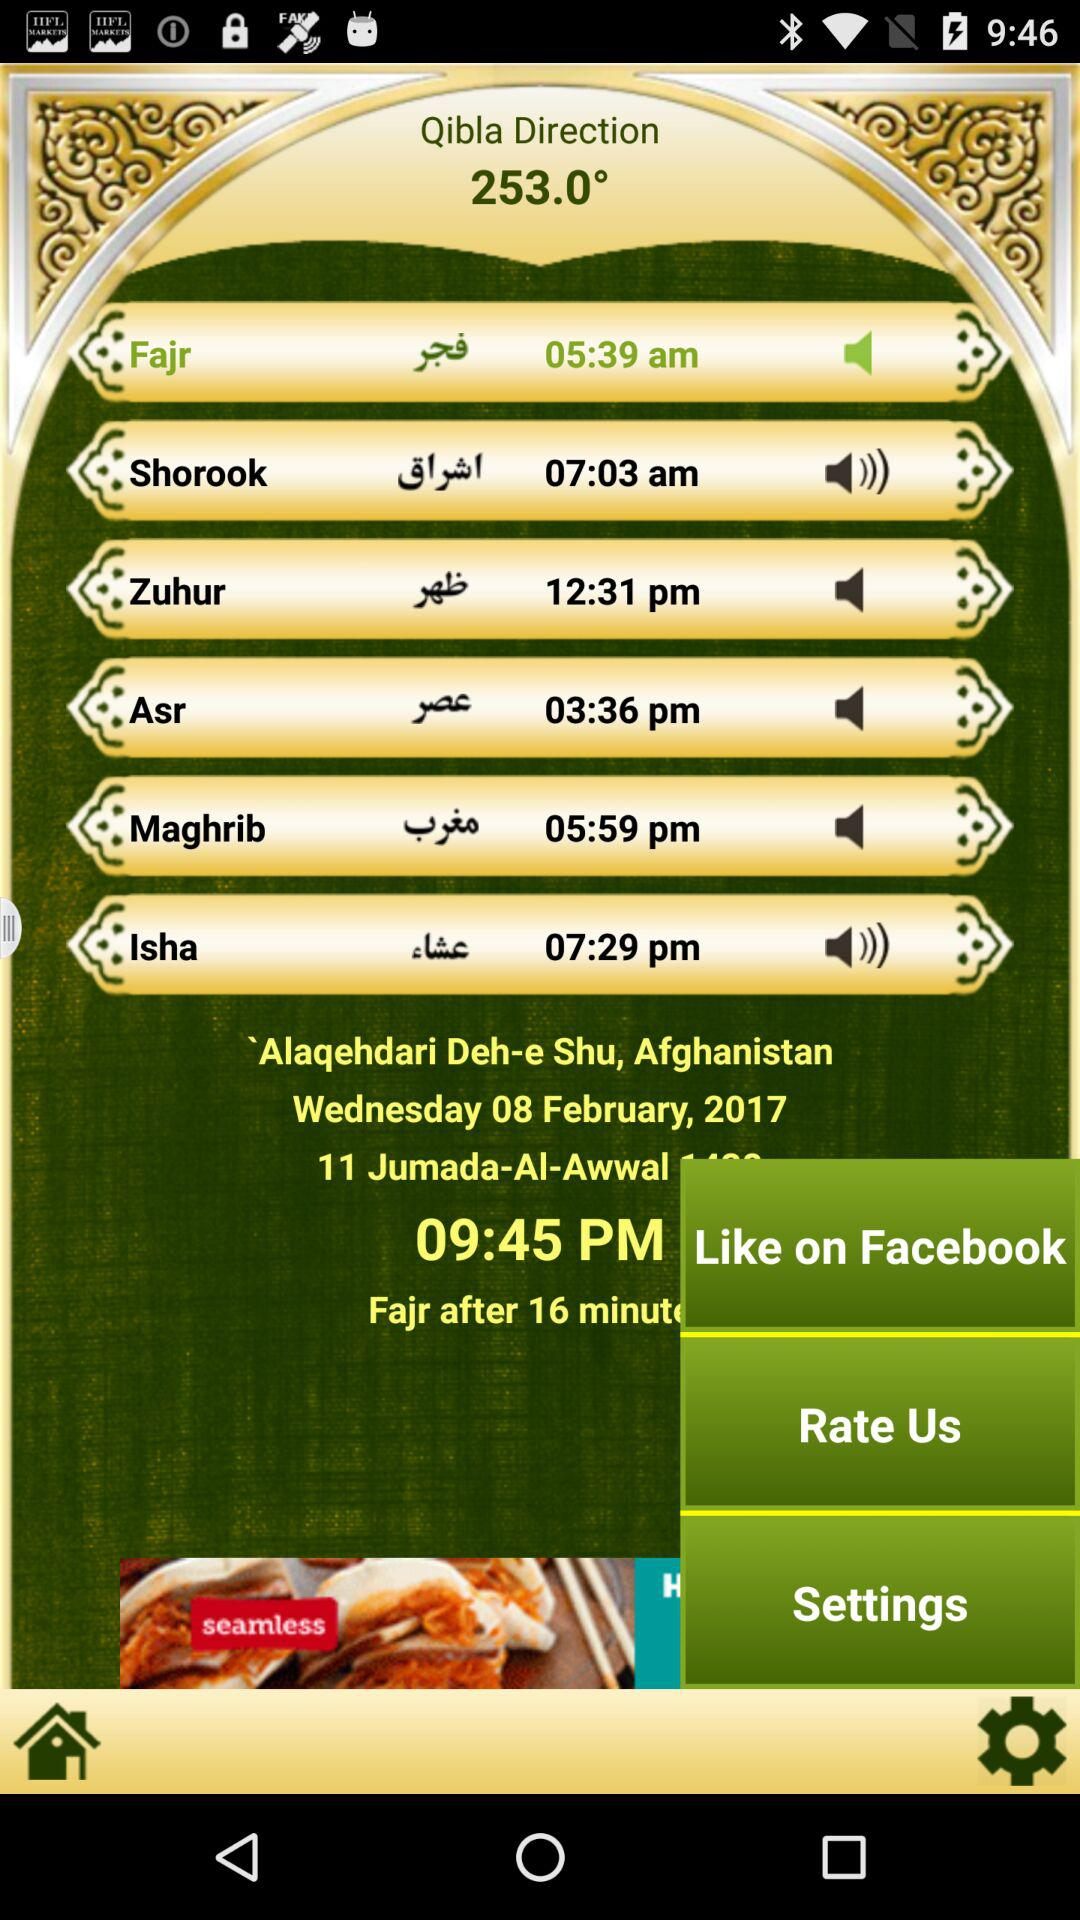What is the direction of the Qibla? The direction is 253.0 degrees. 